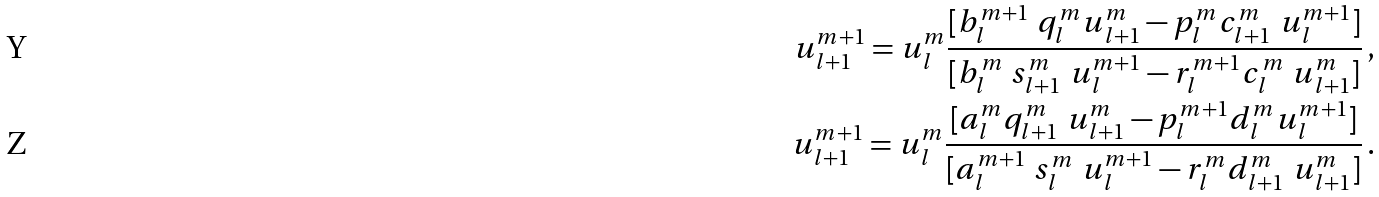<formula> <loc_0><loc_0><loc_500><loc_500>u _ { l + 1 } ^ { m + 1 } = u _ { l } ^ { m } \frac { [ b _ { l } ^ { m + 1 } \ q _ { l } ^ { m } u _ { l + 1 } ^ { m } - p _ { l } ^ { m } c _ { l + 1 } ^ { m } \ u _ { l } ^ { m + 1 } ] } { [ b _ { l } ^ { m } \ s _ { l + 1 } ^ { m } \ u _ { l } ^ { m + 1 } - r _ { l } ^ { m + 1 } c _ { l } ^ { m } \ u _ { l + 1 } ^ { m } ] } \, , \\ u _ { l + 1 } ^ { m + 1 } = u _ { l } ^ { m } \frac { [ a _ { l } ^ { m } q _ { l + 1 } ^ { m } \ u _ { l + 1 } ^ { m } - p _ { l } ^ { m + 1 } d _ { l } ^ { m } u _ { l } ^ { m + 1 } ] } { [ a _ { l } ^ { m + 1 } \ s _ { l } ^ { m } \ u _ { l } ^ { m + 1 } - r _ { l } ^ { m } d _ { l + 1 } ^ { m } \ u _ { l + 1 } ^ { m } ] } \, .</formula> 